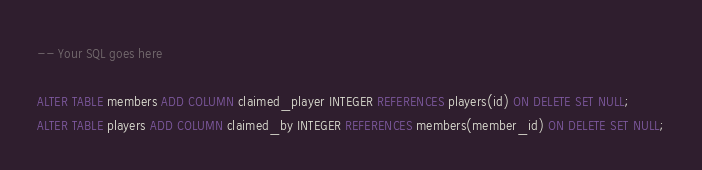Convert code to text. <code><loc_0><loc_0><loc_500><loc_500><_SQL_>-- Your SQL goes here

ALTER TABLE members ADD COLUMN claimed_player INTEGER REFERENCES players(id) ON DELETE SET NULL;
ALTER TABLE players ADD COLUMN claimed_by INTEGER REFERENCES members(member_id) ON DELETE SET NULL;
</code> 